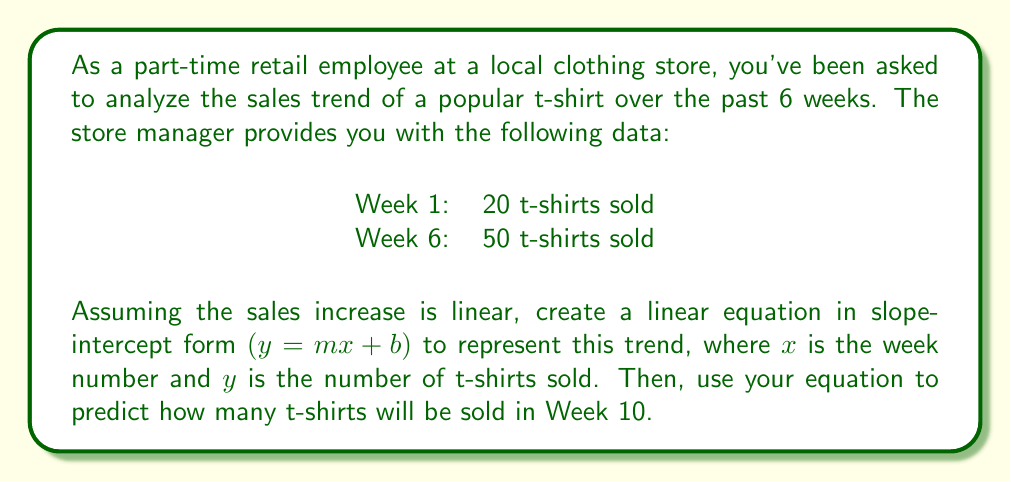Solve this math problem. To solve this problem, let's follow these steps:

1. Find the slope (m) of the line:
   $m = \frac{y_2 - y_1}{x_2 - x_1} = \frac{50 - 20}{6 - 1} = \frac{30}{5} = 6$

2. Use the point-slope form of a line to create an equation:
   $y - y_1 = m(x - x_1)$
   $y - 20 = 6(x - 1)$

3. Simplify to get the slope-intercept form:
   $y - 20 = 6x - 6$
   $y = 6x - 6 + 20$
   $y = 6x + 14$

So, the linear equation representing the sales trend is:
$y = 6x + 14$

4. To predict sales for Week 10, substitute $x = 10$ into the equation:
   $y = 6(10) + 14$
   $y = 60 + 14$
   $y = 74$

Therefore, the prediction for Week 10 is 74 t-shirts.
Answer: The linear equation representing the sales trend is $y = 6x + 14$, where $x$ is the week number and $y$ is the number of t-shirts sold. The predicted number of t-shirts sold in Week 10 is 74. 